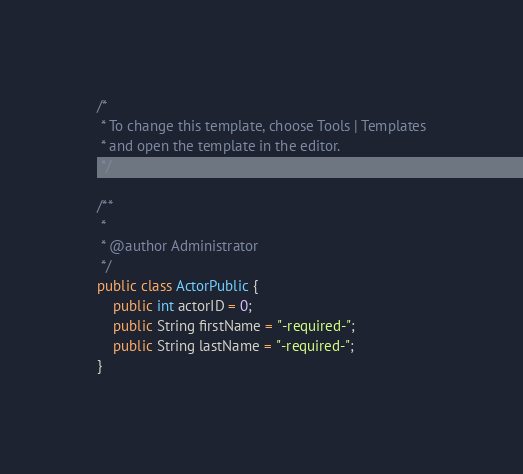<code> <loc_0><loc_0><loc_500><loc_500><_Java_>/*
 * To change this template, choose Tools | Templates
 * and open the template in the editor.
 */

/**
 *
 * @author Administrator
 */
public class ActorPublic {
    public int actorID = 0;
    public String firstName = "-required-";
    public String lastName = "-required-";
}
</code> 